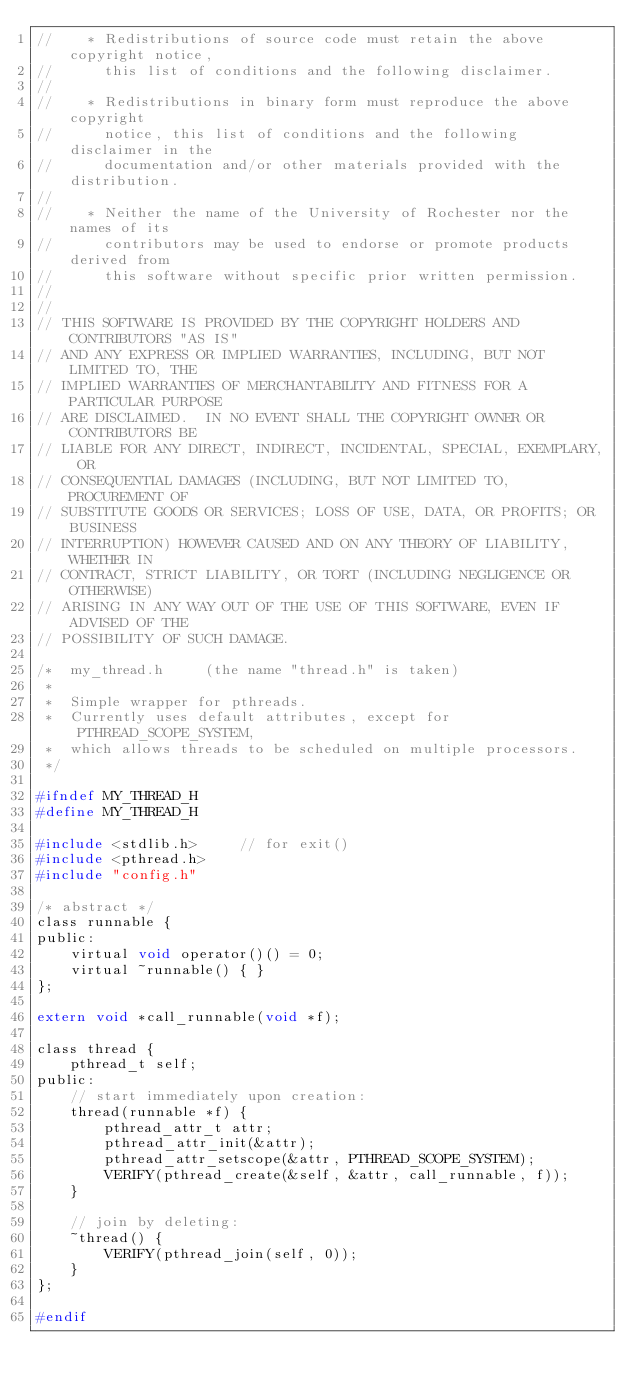Convert code to text. <code><loc_0><loc_0><loc_500><loc_500><_C_>//    * Redistributions of source code must retain the above copyright notice,
//      this list of conditions and the following disclaimer.
//
//    * Redistributions in binary form must reproduce the above copyright
//      notice, this list of conditions and the following disclaimer in the
//      documentation and/or other materials provided with the distribution.
//
//    * Neither the name of the University of Rochester nor the names of its
//      contributors may be used to endorse or promote products derived from
//      this software without specific prior written permission.
//
//
// THIS SOFTWARE IS PROVIDED BY THE COPYRIGHT HOLDERS AND CONTRIBUTORS "AS IS"
// AND ANY EXPRESS OR IMPLIED WARRANTIES, INCLUDING, BUT NOT LIMITED TO, THE
// IMPLIED WARRANTIES OF MERCHANTABILITY AND FITNESS FOR A PARTICULAR PURPOSE
// ARE DISCLAIMED.  IN NO EVENT SHALL THE COPYRIGHT OWNER OR CONTRIBUTORS BE
// LIABLE FOR ANY DIRECT, INDIRECT, INCIDENTAL, SPECIAL, EXEMPLARY, OR
// CONSEQUENTIAL DAMAGES (INCLUDING, BUT NOT LIMITED TO, PROCUREMENT OF
// SUBSTITUTE GOODS OR SERVICES; LOSS OF USE, DATA, OR PROFITS; OR BUSINESS
// INTERRUPTION) HOWEVER CAUSED AND ON ANY THEORY OF LIABILITY, WHETHER IN
// CONTRACT, STRICT LIABILITY, OR TORT (INCLUDING NEGLIGENCE OR OTHERWISE)
// ARISING IN ANY WAY OUT OF THE USE OF THIS SOFTWARE, EVEN IF ADVISED OF THE
// POSSIBILITY OF SUCH DAMAGE.

/*  my_thread.h     (the name "thread.h" is taken)
 *
 *  Simple wrapper for pthreads.
 *  Currently uses default attributes, except for PTHREAD_SCOPE_SYSTEM,
 *  which allows threads to be scheduled on multiple processors.
 */

#ifndef MY_THREAD_H
#define MY_THREAD_H

#include <stdlib.h>     // for exit()
#include <pthread.h>
#include "config.h"

/* abstract */
class runnable {
public:
    virtual void operator()() = 0;
    virtual ~runnable() { }
};

extern void *call_runnable(void *f);

class thread {
    pthread_t self;
public:
    // start immediately upon creation:
    thread(runnable *f) {
        pthread_attr_t attr;
        pthread_attr_init(&attr);
        pthread_attr_setscope(&attr, PTHREAD_SCOPE_SYSTEM);
        VERIFY(pthread_create(&self, &attr, call_runnable, f));
    }

    // join by deleting:
    ~thread() {
        VERIFY(pthread_join(self, 0));
    }
};

#endif
</code> 